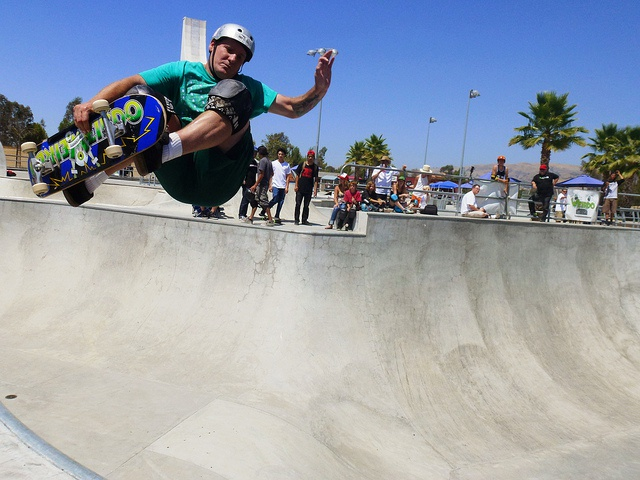Describe the objects in this image and their specific colors. I can see people in gray, black, maroon, and brown tones, skateboard in gray, black, darkgray, and darkblue tones, people in gray, black, lightgray, and maroon tones, people in gray, black, maroon, and darkgray tones, and people in gray, black, darkgray, and maroon tones in this image. 